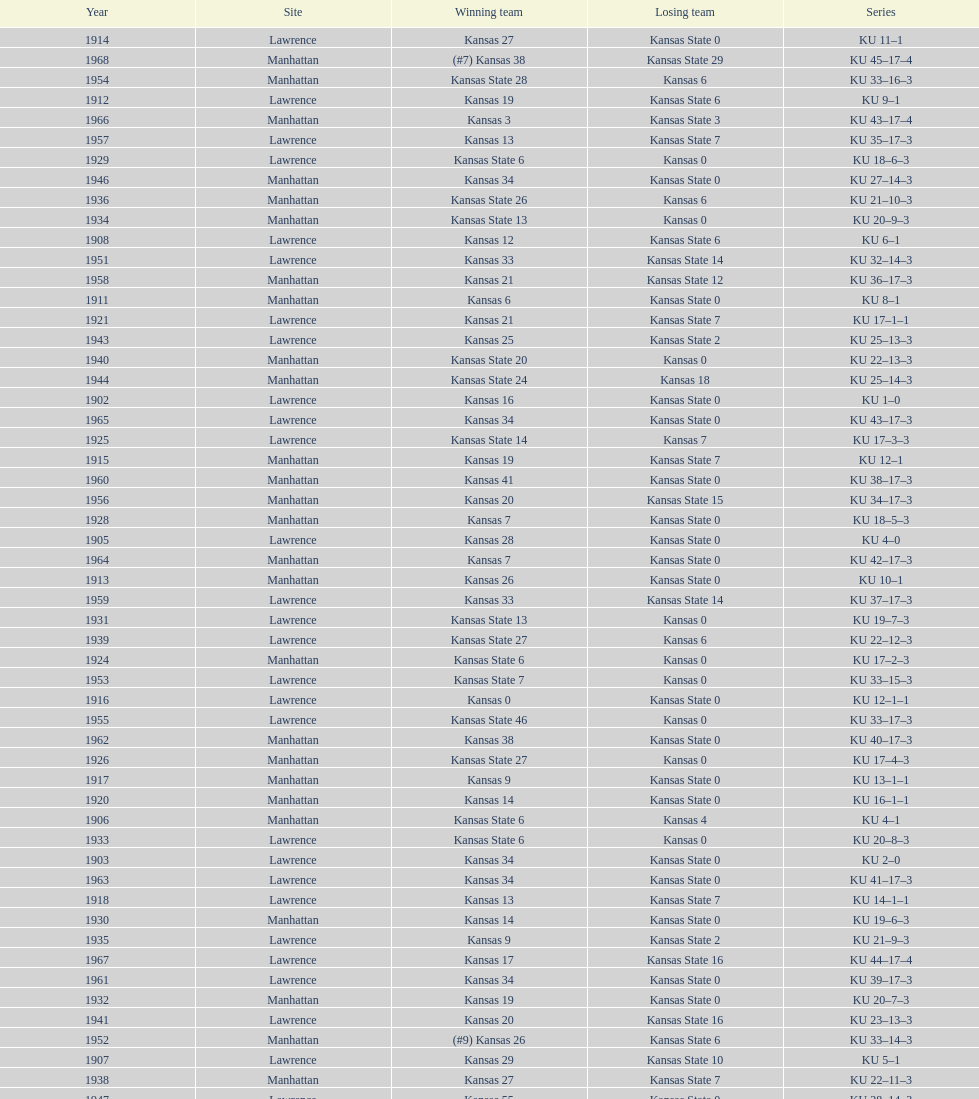What is the total number of games played? 66. 